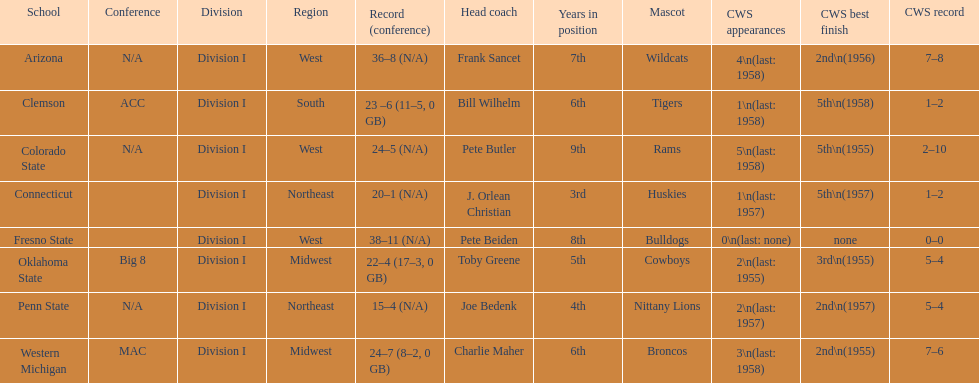Which school has no cws appearances? Fresno State. 